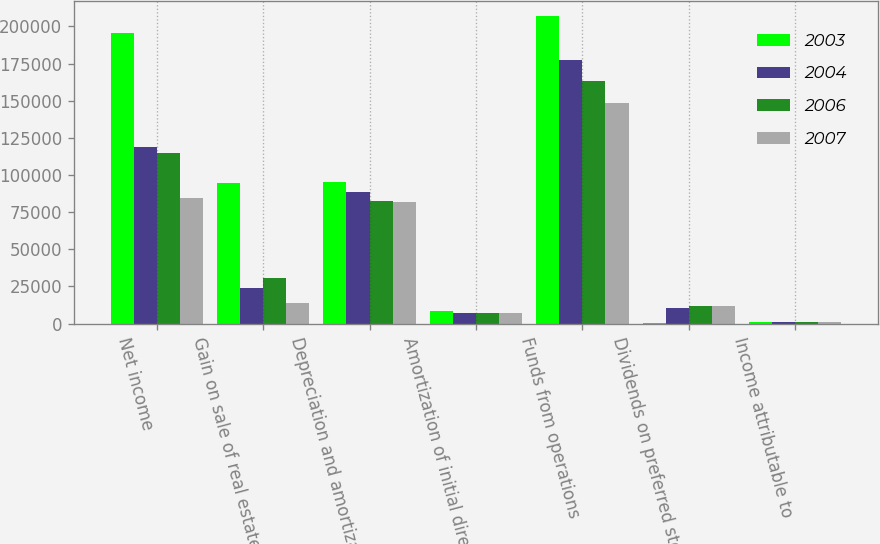Convert chart. <chart><loc_0><loc_0><loc_500><loc_500><stacked_bar_chart><ecel><fcel>Net income<fcel>Gain on sale of real estate<fcel>Depreciation and amortization<fcel>Amortization of initial direct<fcel>Funds from operations<fcel>Dividends on preferred stock<fcel>Income attributable to<nl><fcel>2003<fcel>195537<fcel>94768<fcel>95565<fcel>8473<fcel>206762<fcel>442<fcel>1156<nl><fcel>2004<fcel>118712<fcel>23956<fcel>88649<fcel>7390<fcel>177113<fcel>10423<fcel>748<nl><fcel>2006<fcel>114612<fcel>30748<fcel>82752<fcel>6972<fcel>163544<fcel>11475<fcel>801<nl><fcel>2007<fcel>84156<fcel>14052<fcel>81649<fcel>7151<fcel>148671<fcel>11475<fcel>1055<nl></chart> 